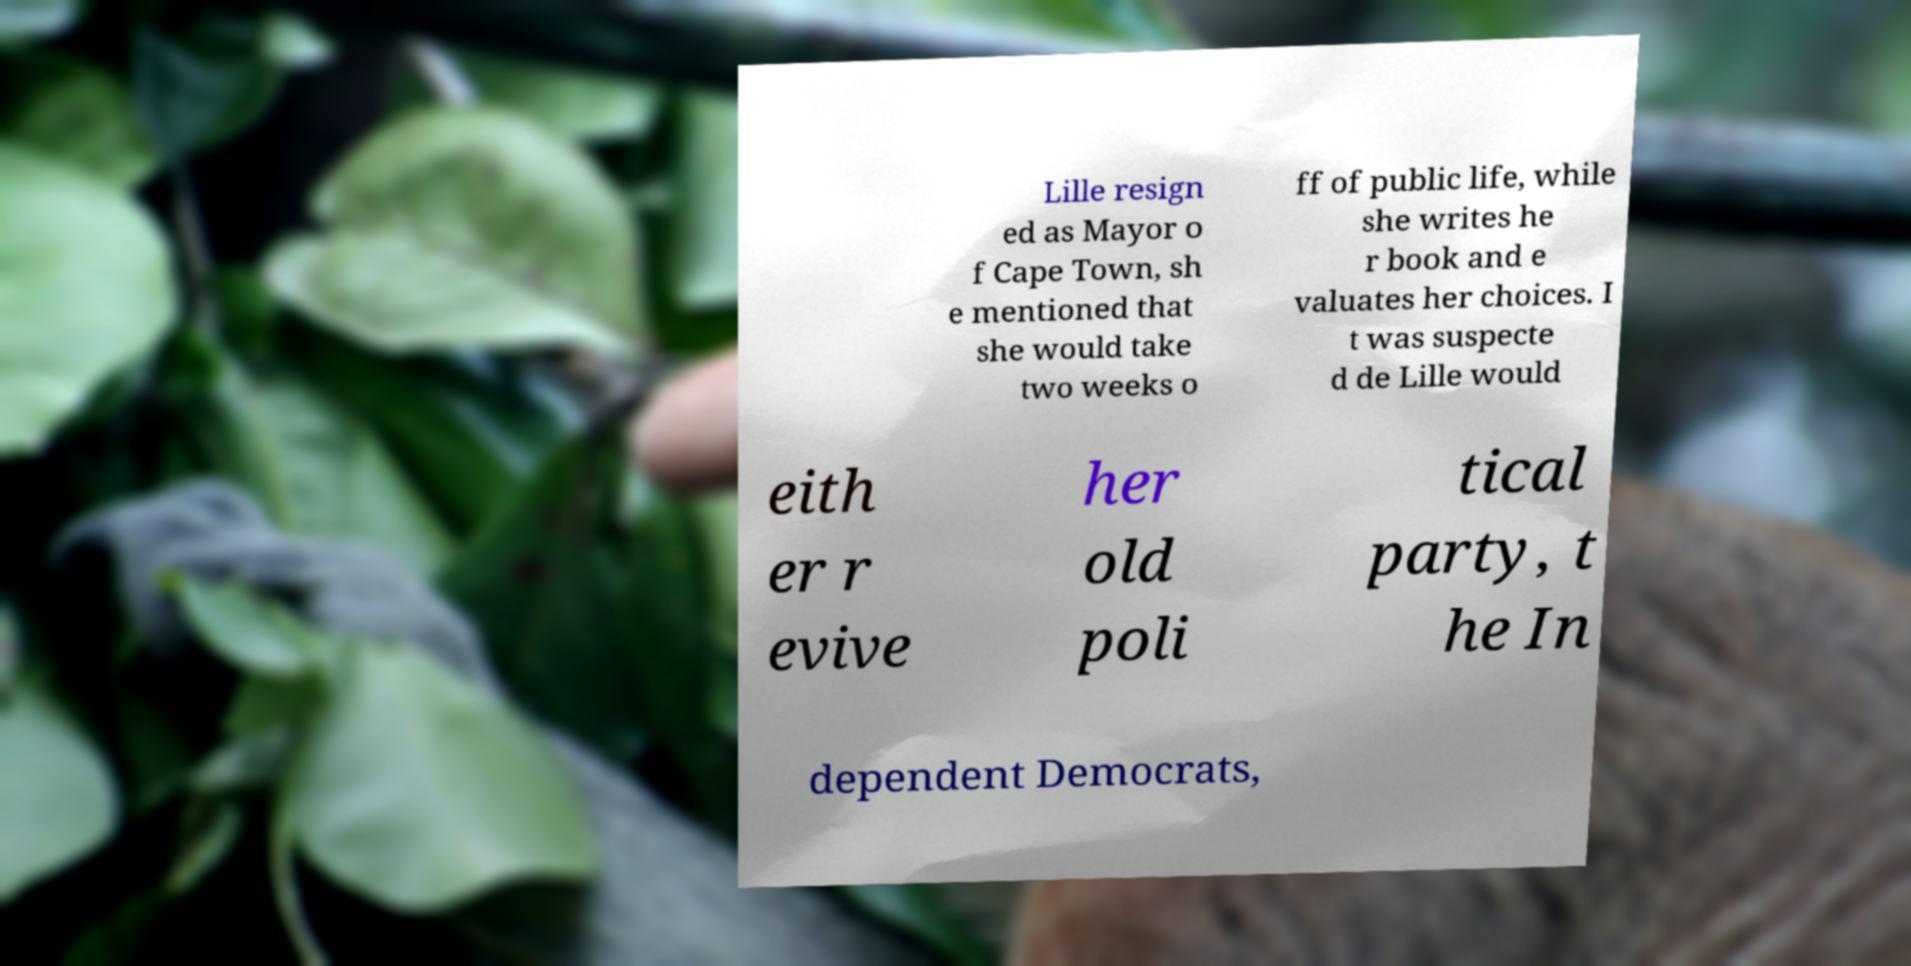For documentation purposes, I need the text within this image transcribed. Could you provide that? Lille resign ed as Mayor o f Cape Town, sh e mentioned that she would take two weeks o ff of public life, while she writes he r book and e valuates her choices. I t was suspecte d de Lille would eith er r evive her old poli tical party, t he In dependent Democrats, 